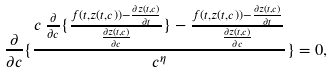Convert formula to latex. <formula><loc_0><loc_0><loc_500><loc_500>\frac { \partial } { \partial c } \{ \frac { c \, \frac { \partial } { \partial c } \{ \frac { f ( t , z ( t , c ) ) - \frac { \partial z ( t , c ) } { \partial t } } { \frac { \partial z ( t , c ) } { \partial c } } \} - \frac { f ( t , z ( t , c ) ) - \frac { \partial z ( t , c ) } { \partial t } } { \frac { \partial z ( t , c ) } { \partial c } } } { c ^ { \eta } } \} = 0 ,</formula> 